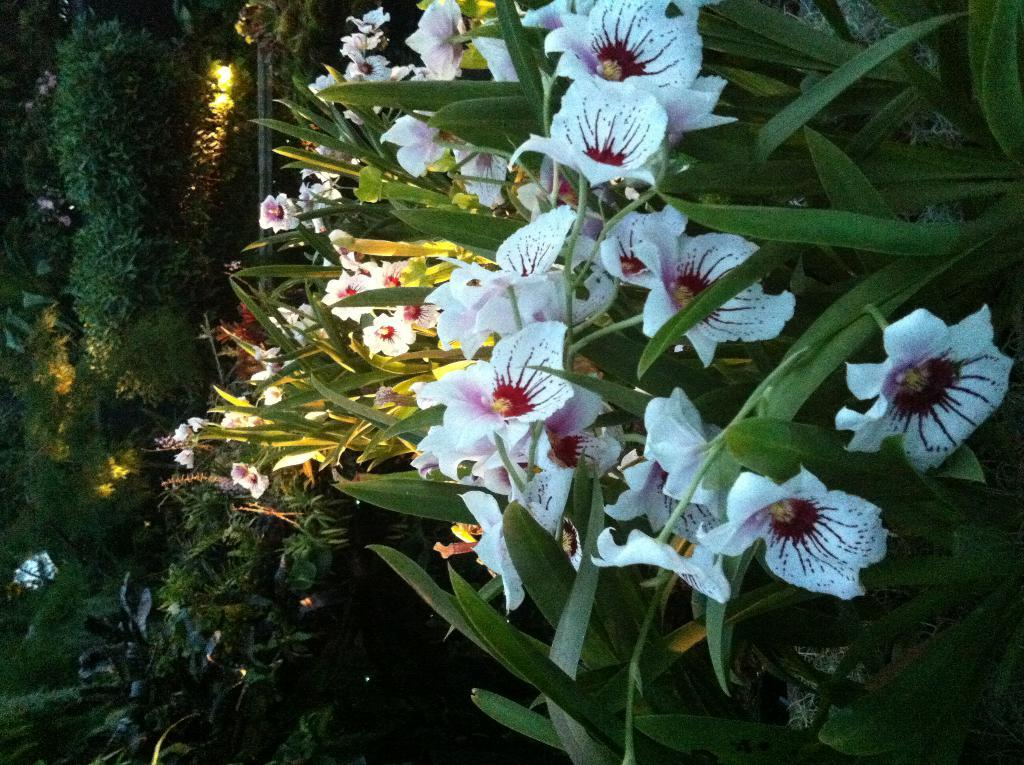What type of plants are in the image? There are white color flower plants in the image. Where are the flower plants located in the image? The flower plants are on the left side of the image. How many eyes can be seen on the flower plants in the image? There are no eyes visible on the flower plants in the image, as they are not living beings with eyes. 